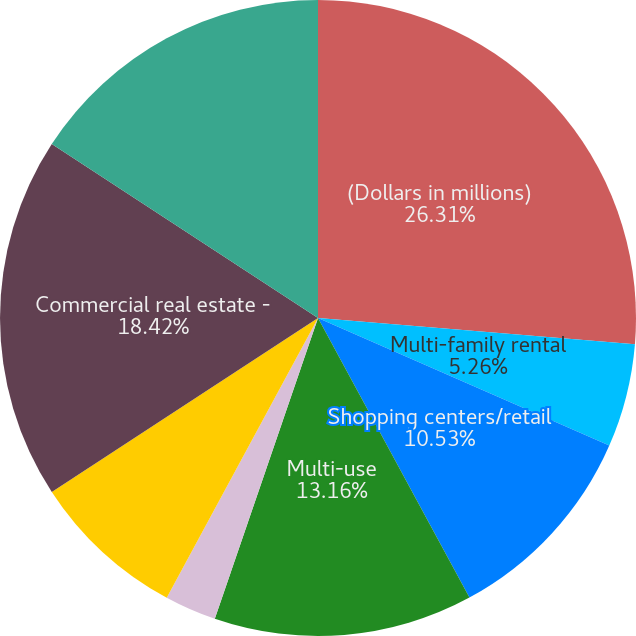<chart> <loc_0><loc_0><loc_500><loc_500><pie_chart><fcel>(Dollars in millions)<fcel>Multi-family rental<fcel>Shopping centers/retail<fcel>Hotels/motels<fcel>Multi-use<fcel>Other (4)<fcel>Total non-homebuilder<fcel>Commercial real estate -<fcel>Total commercial real estate<nl><fcel>26.31%<fcel>5.26%<fcel>10.53%<fcel>0.0%<fcel>13.16%<fcel>2.63%<fcel>7.9%<fcel>18.42%<fcel>15.79%<nl></chart> 